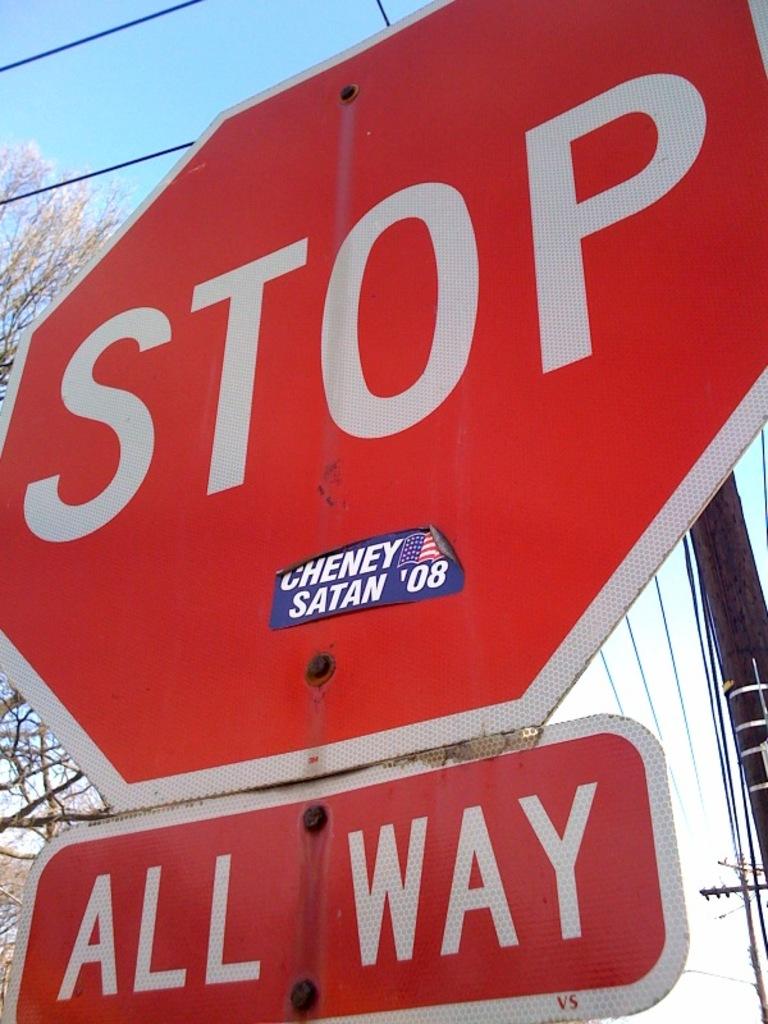What sticker is on the stop sign?
Ensure brevity in your answer.  Cheney satan '08. 